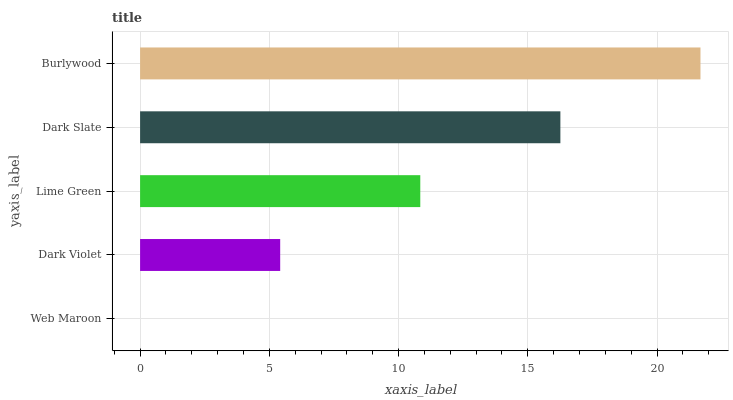Is Web Maroon the minimum?
Answer yes or no. Yes. Is Burlywood the maximum?
Answer yes or no. Yes. Is Dark Violet the minimum?
Answer yes or no. No. Is Dark Violet the maximum?
Answer yes or no. No. Is Dark Violet greater than Web Maroon?
Answer yes or no. Yes. Is Web Maroon less than Dark Violet?
Answer yes or no. Yes. Is Web Maroon greater than Dark Violet?
Answer yes or no. No. Is Dark Violet less than Web Maroon?
Answer yes or no. No. Is Lime Green the high median?
Answer yes or no. Yes. Is Lime Green the low median?
Answer yes or no. Yes. Is Dark Violet the high median?
Answer yes or no. No. Is Burlywood the low median?
Answer yes or no. No. 